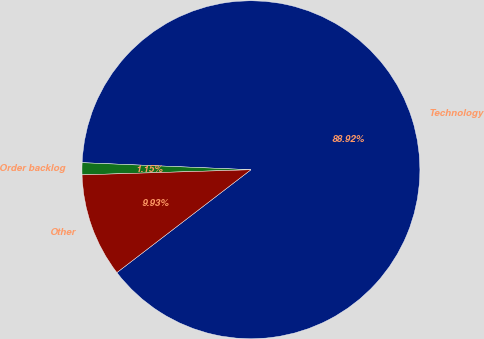Convert chart to OTSL. <chart><loc_0><loc_0><loc_500><loc_500><pie_chart><fcel>Technology<fcel>Order backlog<fcel>Other<nl><fcel>88.91%<fcel>1.15%<fcel>9.93%<nl></chart> 